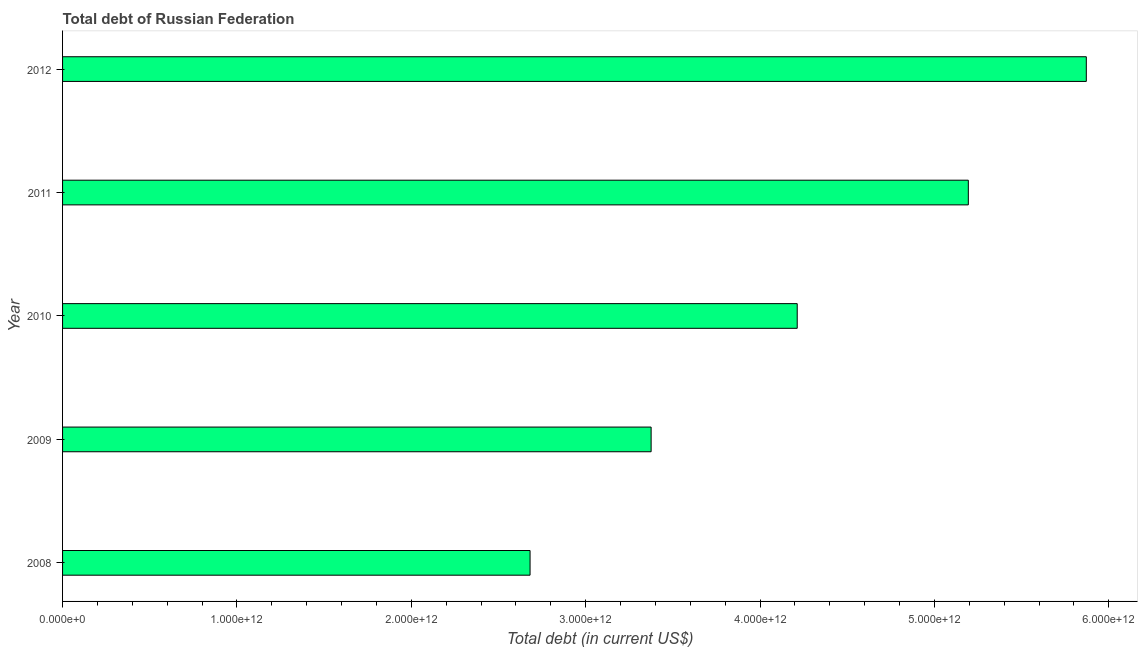Does the graph contain grids?
Provide a short and direct response. No. What is the title of the graph?
Offer a very short reply. Total debt of Russian Federation. What is the label or title of the X-axis?
Your answer should be compact. Total debt (in current US$). What is the total debt in 2011?
Your answer should be compact. 5.19e+12. Across all years, what is the maximum total debt?
Your answer should be very brief. 5.87e+12. Across all years, what is the minimum total debt?
Provide a short and direct response. 2.68e+12. In which year was the total debt minimum?
Offer a terse response. 2008. What is the sum of the total debt?
Offer a terse response. 2.13e+13. What is the difference between the total debt in 2008 and 2012?
Ensure brevity in your answer.  -3.19e+12. What is the average total debt per year?
Give a very brief answer. 4.27e+12. What is the median total debt?
Your response must be concise. 4.21e+12. In how many years, is the total debt greater than 1400000000000 US$?
Make the answer very short. 5. Do a majority of the years between 2009 and 2011 (inclusive) have total debt greater than 1800000000000 US$?
Your answer should be compact. Yes. What is the ratio of the total debt in 2011 to that in 2012?
Offer a very short reply. 0.89. Is the difference between the total debt in 2008 and 2009 greater than the difference between any two years?
Make the answer very short. No. What is the difference between the highest and the second highest total debt?
Your answer should be very brief. 6.77e+11. Is the sum of the total debt in 2008 and 2010 greater than the maximum total debt across all years?
Provide a succinct answer. Yes. What is the difference between the highest and the lowest total debt?
Make the answer very short. 3.19e+12. In how many years, is the total debt greater than the average total debt taken over all years?
Offer a terse response. 2. Are all the bars in the graph horizontal?
Your response must be concise. Yes. How many years are there in the graph?
Your answer should be compact. 5. What is the difference between two consecutive major ticks on the X-axis?
Give a very brief answer. 1.00e+12. Are the values on the major ticks of X-axis written in scientific E-notation?
Keep it short and to the point. Yes. What is the Total debt (in current US$) in 2008?
Ensure brevity in your answer.  2.68e+12. What is the Total debt (in current US$) of 2009?
Provide a succinct answer. 3.38e+12. What is the Total debt (in current US$) in 2010?
Offer a very short reply. 4.21e+12. What is the Total debt (in current US$) in 2011?
Ensure brevity in your answer.  5.19e+12. What is the Total debt (in current US$) in 2012?
Provide a short and direct response. 5.87e+12. What is the difference between the Total debt (in current US$) in 2008 and 2009?
Ensure brevity in your answer.  -6.94e+11. What is the difference between the Total debt (in current US$) in 2008 and 2010?
Provide a short and direct response. -1.53e+12. What is the difference between the Total debt (in current US$) in 2008 and 2011?
Your answer should be compact. -2.51e+12. What is the difference between the Total debt (in current US$) in 2008 and 2012?
Your response must be concise. -3.19e+12. What is the difference between the Total debt (in current US$) in 2009 and 2010?
Provide a short and direct response. -8.38e+11. What is the difference between the Total debt (in current US$) in 2009 and 2011?
Ensure brevity in your answer.  -1.82e+12. What is the difference between the Total debt (in current US$) in 2009 and 2012?
Keep it short and to the point. -2.50e+12. What is the difference between the Total debt (in current US$) in 2010 and 2011?
Keep it short and to the point. -9.81e+11. What is the difference between the Total debt (in current US$) in 2010 and 2012?
Offer a very short reply. -1.66e+12. What is the difference between the Total debt (in current US$) in 2011 and 2012?
Give a very brief answer. -6.77e+11. What is the ratio of the Total debt (in current US$) in 2008 to that in 2009?
Offer a very short reply. 0.79. What is the ratio of the Total debt (in current US$) in 2008 to that in 2010?
Your response must be concise. 0.64. What is the ratio of the Total debt (in current US$) in 2008 to that in 2011?
Make the answer very short. 0.52. What is the ratio of the Total debt (in current US$) in 2008 to that in 2012?
Ensure brevity in your answer.  0.46. What is the ratio of the Total debt (in current US$) in 2009 to that in 2010?
Your response must be concise. 0.8. What is the ratio of the Total debt (in current US$) in 2009 to that in 2011?
Keep it short and to the point. 0.65. What is the ratio of the Total debt (in current US$) in 2009 to that in 2012?
Your answer should be compact. 0.57. What is the ratio of the Total debt (in current US$) in 2010 to that in 2011?
Give a very brief answer. 0.81. What is the ratio of the Total debt (in current US$) in 2010 to that in 2012?
Keep it short and to the point. 0.72. What is the ratio of the Total debt (in current US$) in 2011 to that in 2012?
Offer a very short reply. 0.89. 